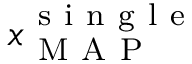Convert formula to latex. <formula><loc_0><loc_0><loc_500><loc_500>x _ { M A P } ^ { s i n g l e }</formula> 